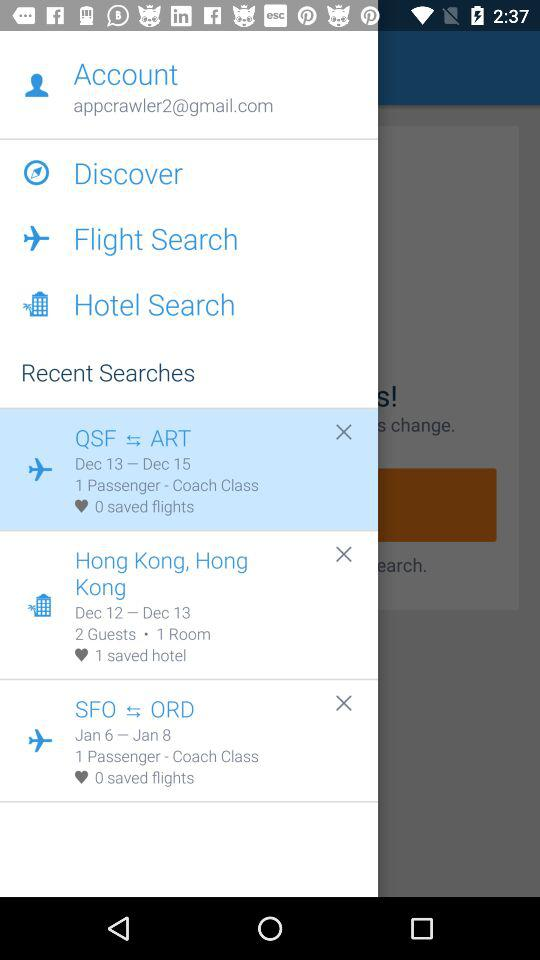How many saved searches are there in total?
Answer the question using a single word or phrase. 3 